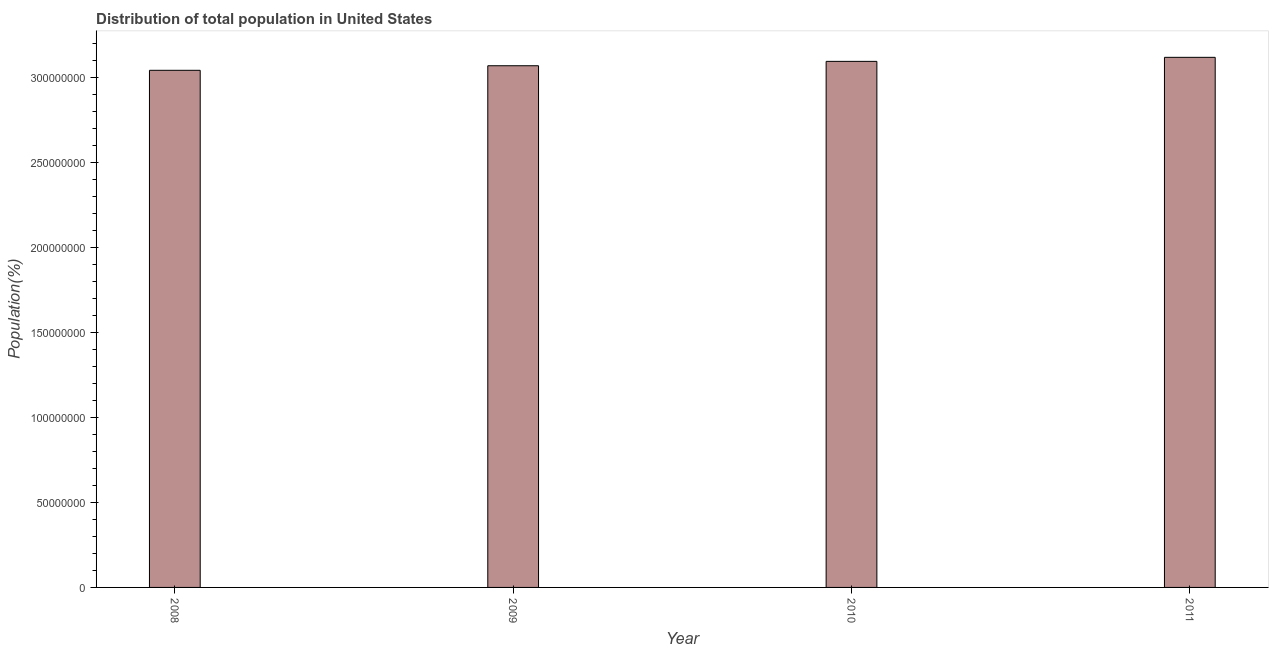Does the graph contain any zero values?
Keep it short and to the point. No. What is the title of the graph?
Your answer should be very brief. Distribution of total population in United States . What is the label or title of the X-axis?
Offer a terse response. Year. What is the label or title of the Y-axis?
Your answer should be very brief. Population(%). What is the population in 2010?
Make the answer very short. 3.09e+08. Across all years, what is the maximum population?
Offer a very short reply. 3.12e+08. Across all years, what is the minimum population?
Offer a terse response. 3.04e+08. In which year was the population minimum?
Give a very brief answer. 2008. What is the sum of the population?
Provide a succinct answer. 1.23e+09. What is the difference between the population in 2008 and 2009?
Offer a terse response. -2.68e+06. What is the average population per year?
Offer a terse response. 3.08e+08. What is the median population?
Provide a short and direct response. 3.08e+08. Is the difference between the population in 2008 and 2011 greater than the difference between any two years?
Provide a short and direct response. Yes. What is the difference between the highest and the second highest population?
Provide a short and direct response. 2.37e+06. Is the sum of the population in 2009 and 2011 greater than the maximum population across all years?
Make the answer very short. Yes. What is the difference between the highest and the lowest population?
Offer a very short reply. 7.63e+06. In how many years, is the population greater than the average population taken over all years?
Offer a very short reply. 2. Are all the bars in the graph horizontal?
Make the answer very short. No. Are the values on the major ticks of Y-axis written in scientific E-notation?
Keep it short and to the point. No. What is the Population(%) in 2008?
Give a very brief answer. 3.04e+08. What is the Population(%) in 2009?
Keep it short and to the point. 3.07e+08. What is the Population(%) in 2010?
Provide a succinct answer. 3.09e+08. What is the Population(%) in 2011?
Your answer should be compact. 3.12e+08. What is the difference between the Population(%) in 2008 and 2009?
Your answer should be compact. -2.68e+06. What is the difference between the Population(%) in 2008 and 2010?
Give a very brief answer. -5.25e+06. What is the difference between the Population(%) in 2008 and 2011?
Ensure brevity in your answer.  -7.63e+06. What is the difference between the Population(%) in 2009 and 2010?
Your response must be concise. -2.58e+06. What is the difference between the Population(%) in 2009 and 2011?
Provide a short and direct response. -4.95e+06. What is the difference between the Population(%) in 2010 and 2011?
Provide a succinct answer. -2.37e+06. What is the ratio of the Population(%) in 2008 to that in 2011?
Offer a very short reply. 0.98. What is the ratio of the Population(%) in 2009 to that in 2011?
Ensure brevity in your answer.  0.98. What is the ratio of the Population(%) in 2010 to that in 2011?
Provide a short and direct response. 0.99. 